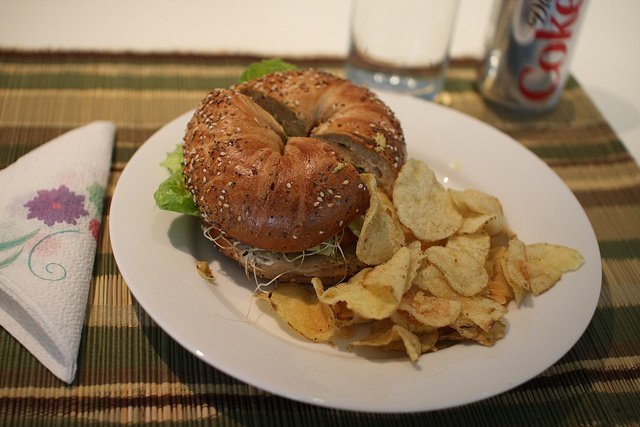Describe the objects in this image and their specific colors. I can see dining table in tan, darkgray, olive, black, and maroon tones, sandwich in tan, brown, maroon, olive, and gray tones, and cup in tan, beige, darkgray, and gray tones in this image. 